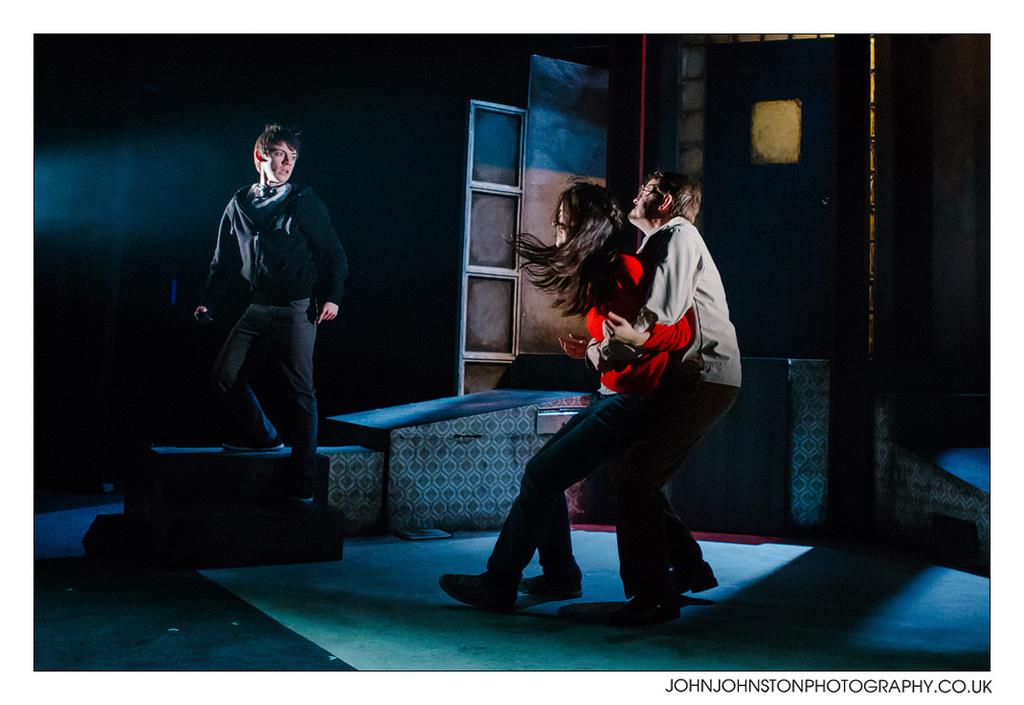How many people are in the image? There are three people in the image: one woman and two men. What is written or depicted in the bottom right corner of the image? There is text in the bottom right corner of the image. What is the color of the background in the image? The background of the image is dark. How many pigs are visible in the image? There are no pigs present in the image. What type of zipper is being used by the woman in the image? There is no zipper visible in the image, as it features a woman and two men without any clothing or accessories mentioned. 